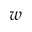<formula> <loc_0><loc_0><loc_500><loc_500>w</formula> 